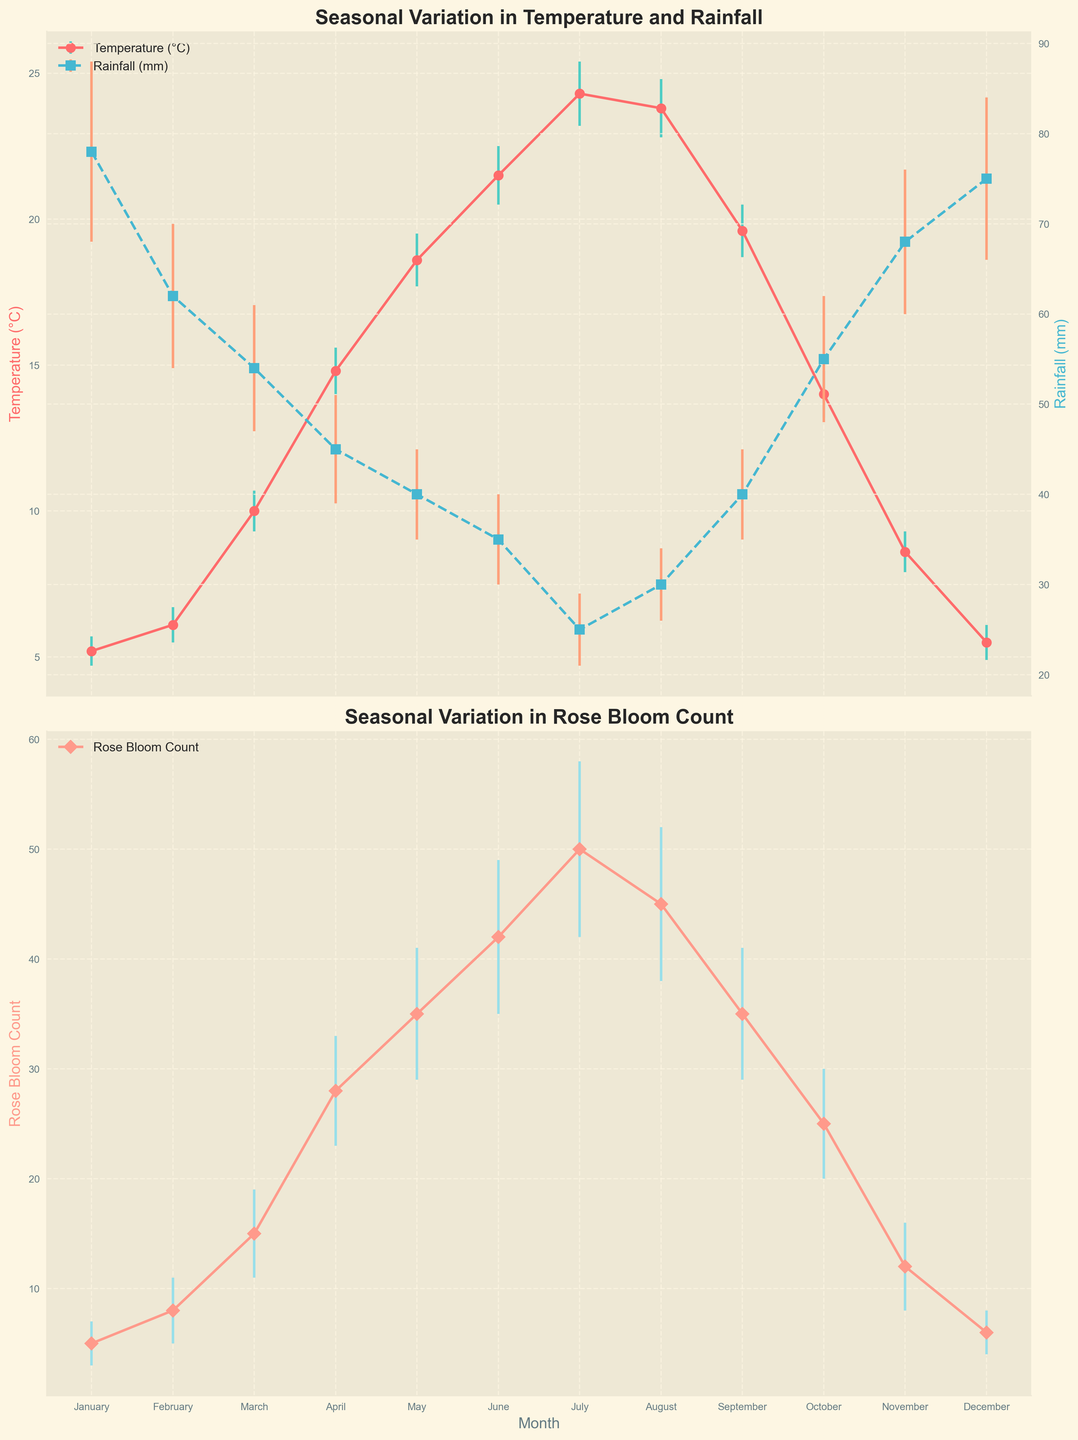What is the title of the temperature and rainfall subplot? The title is located at the top of the first subplot and it reads 'Seasonal Variation in Temperature and Rainfall'.
Answer: Seasonal Variation in Temperature and Rainfall Which month has the highest average temperature? The highest point on the Temperature (°C) line is observed in July on the x-axis.
Answer: July How does the average rainfall in July compare to that in January? The average rainfall in July is 25 mm, while it is 78 mm in January. Comparing these values shows July has significantly less rainfall than January.
Answer: July has less rainfall than January What is the lowest rose bloom count recorded and in which month? The lowest point on the Rose Bloom Count line can be seen at 5 in January.
Answer: 5 in January In which month does the rose bloom count peak and what is the count? The peak of the Rose Bloom Count line occurs in July with a count of 50.
Answer: July with a count of 50 How much does the average temperature increase from March to June? From March (10°C) to June (21.5°C), the temperature increases by 21.5 - 10 = 11.5 degrees Celsius.
Answer: 11.5 degrees Celsius What is the relationship between rainfall and temperature throughout the year? Observing both lines, it is noted that higher temperatures (seen in summer months) generally correspond to lower rainfall and vice versa.
Answer: Higher temperatures generally result in lower rainfall How does the rose bloom count change from April to August? The rose bloom count rises from 28 in April to 45 in August with peaks in between, specifically in July. The pattern is an increase till July and then a slight decrease in August.
Answer: Increase till July, slight decrease in August What is the standard deviation of rose bloom count in November? The error bar in the November rose bloom count indicates a standard deviation of 4.
Answer: 4 